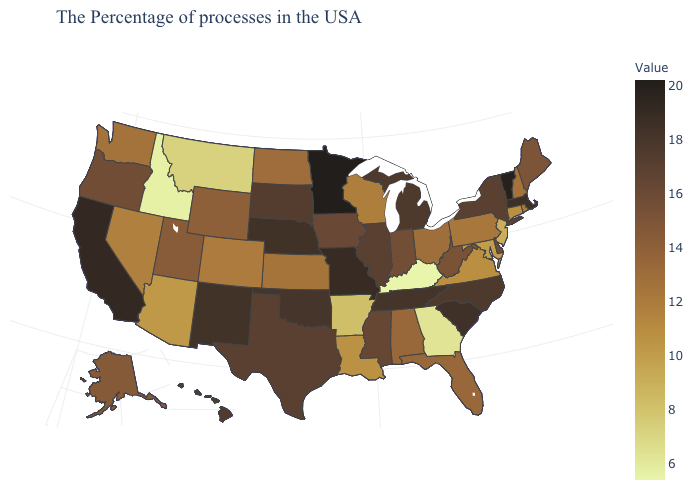Among the states that border Mississippi , does Arkansas have the lowest value?
Answer briefly. Yes. Which states hav the highest value in the MidWest?
Keep it brief. Minnesota. Does Indiana have the lowest value in the USA?
Short answer required. No. Does Rhode Island have a higher value than New Jersey?
Be succinct. Yes. Which states have the lowest value in the South?
Give a very brief answer. Kentucky. Which states have the lowest value in the Northeast?
Quick response, please. New Jersey. 